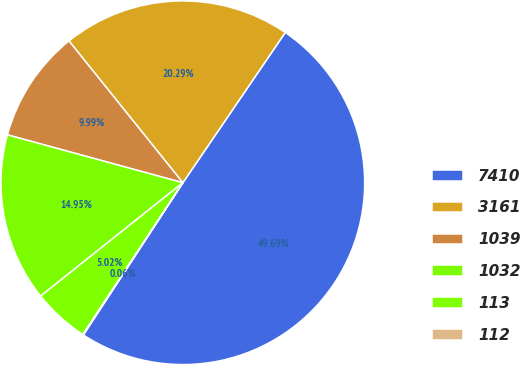Convert chart. <chart><loc_0><loc_0><loc_500><loc_500><pie_chart><fcel>7410<fcel>3161<fcel>1039<fcel>1032<fcel>113<fcel>112<nl><fcel>49.69%<fcel>20.29%<fcel>9.99%<fcel>14.95%<fcel>5.02%<fcel>0.06%<nl></chart> 